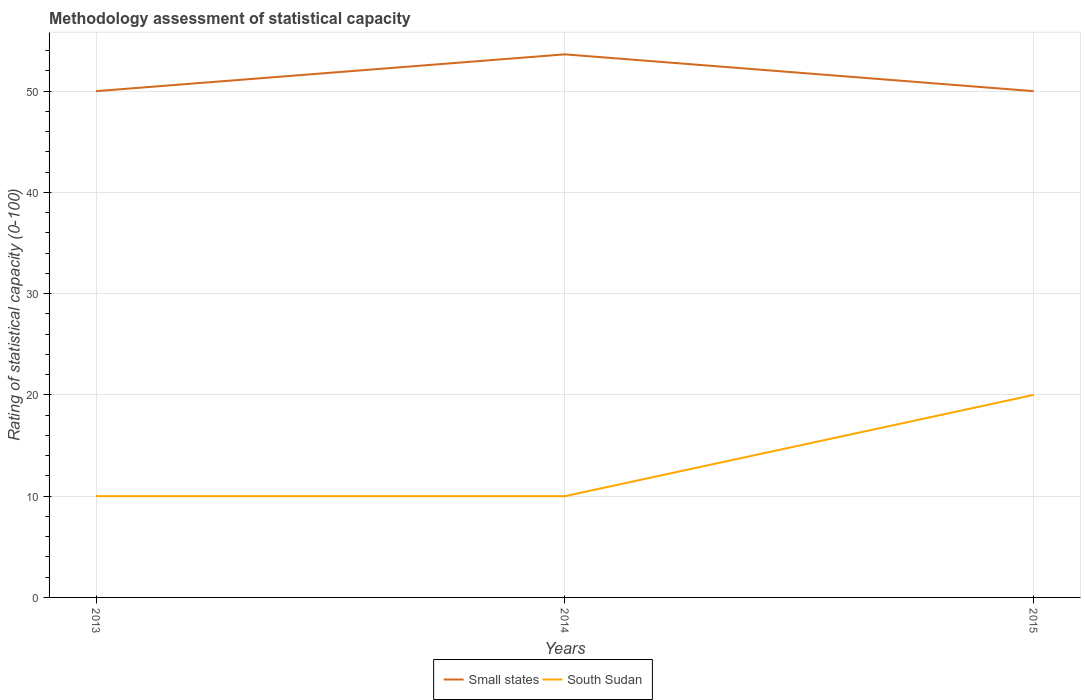How many different coloured lines are there?
Your answer should be very brief. 2. Is the number of lines equal to the number of legend labels?
Offer a very short reply. Yes. Across all years, what is the maximum rating of statistical capacity in South Sudan?
Keep it short and to the point. 10. In which year was the rating of statistical capacity in Small states maximum?
Provide a short and direct response. 2013. What is the difference between the highest and the second highest rating of statistical capacity in South Sudan?
Give a very brief answer. 10. Is the rating of statistical capacity in Small states strictly greater than the rating of statistical capacity in South Sudan over the years?
Your answer should be compact. No. Does the graph contain grids?
Make the answer very short. Yes. How many legend labels are there?
Your answer should be very brief. 2. How are the legend labels stacked?
Make the answer very short. Horizontal. What is the title of the graph?
Ensure brevity in your answer.  Methodology assessment of statistical capacity. What is the label or title of the Y-axis?
Offer a very short reply. Rating of statistical capacity (0-100). What is the Rating of statistical capacity (0-100) in Small states in 2013?
Offer a very short reply. 50. What is the Rating of statistical capacity (0-100) of Small states in 2014?
Your answer should be very brief. 53.64. Across all years, what is the maximum Rating of statistical capacity (0-100) in Small states?
Make the answer very short. 53.64. Across all years, what is the maximum Rating of statistical capacity (0-100) in South Sudan?
Provide a succinct answer. 20. Across all years, what is the minimum Rating of statistical capacity (0-100) in Small states?
Make the answer very short. 50. Across all years, what is the minimum Rating of statistical capacity (0-100) of South Sudan?
Offer a terse response. 10. What is the total Rating of statistical capacity (0-100) of Small states in the graph?
Offer a very short reply. 153.64. What is the difference between the Rating of statistical capacity (0-100) of Small states in 2013 and that in 2014?
Give a very brief answer. -3.64. What is the difference between the Rating of statistical capacity (0-100) of South Sudan in 2013 and that in 2014?
Make the answer very short. 0. What is the difference between the Rating of statistical capacity (0-100) of Small states in 2013 and that in 2015?
Your answer should be very brief. 0. What is the difference between the Rating of statistical capacity (0-100) of South Sudan in 2013 and that in 2015?
Offer a very short reply. -10. What is the difference between the Rating of statistical capacity (0-100) in Small states in 2014 and that in 2015?
Your answer should be compact. 3.64. What is the difference between the Rating of statistical capacity (0-100) in South Sudan in 2014 and that in 2015?
Give a very brief answer. -10. What is the difference between the Rating of statistical capacity (0-100) in Small states in 2013 and the Rating of statistical capacity (0-100) in South Sudan in 2014?
Your answer should be very brief. 40. What is the difference between the Rating of statistical capacity (0-100) of Small states in 2014 and the Rating of statistical capacity (0-100) of South Sudan in 2015?
Your answer should be compact. 33.64. What is the average Rating of statistical capacity (0-100) in Small states per year?
Provide a short and direct response. 51.21. What is the average Rating of statistical capacity (0-100) of South Sudan per year?
Provide a short and direct response. 13.33. In the year 2014, what is the difference between the Rating of statistical capacity (0-100) of Small states and Rating of statistical capacity (0-100) of South Sudan?
Offer a terse response. 43.64. What is the ratio of the Rating of statistical capacity (0-100) of Small states in 2013 to that in 2014?
Make the answer very short. 0.93. What is the ratio of the Rating of statistical capacity (0-100) in South Sudan in 2013 to that in 2014?
Your answer should be compact. 1. What is the ratio of the Rating of statistical capacity (0-100) in Small states in 2014 to that in 2015?
Provide a short and direct response. 1.07. What is the difference between the highest and the second highest Rating of statistical capacity (0-100) in Small states?
Your answer should be compact. 3.64. What is the difference between the highest and the lowest Rating of statistical capacity (0-100) in Small states?
Your answer should be very brief. 3.64. What is the difference between the highest and the lowest Rating of statistical capacity (0-100) of South Sudan?
Keep it short and to the point. 10. 